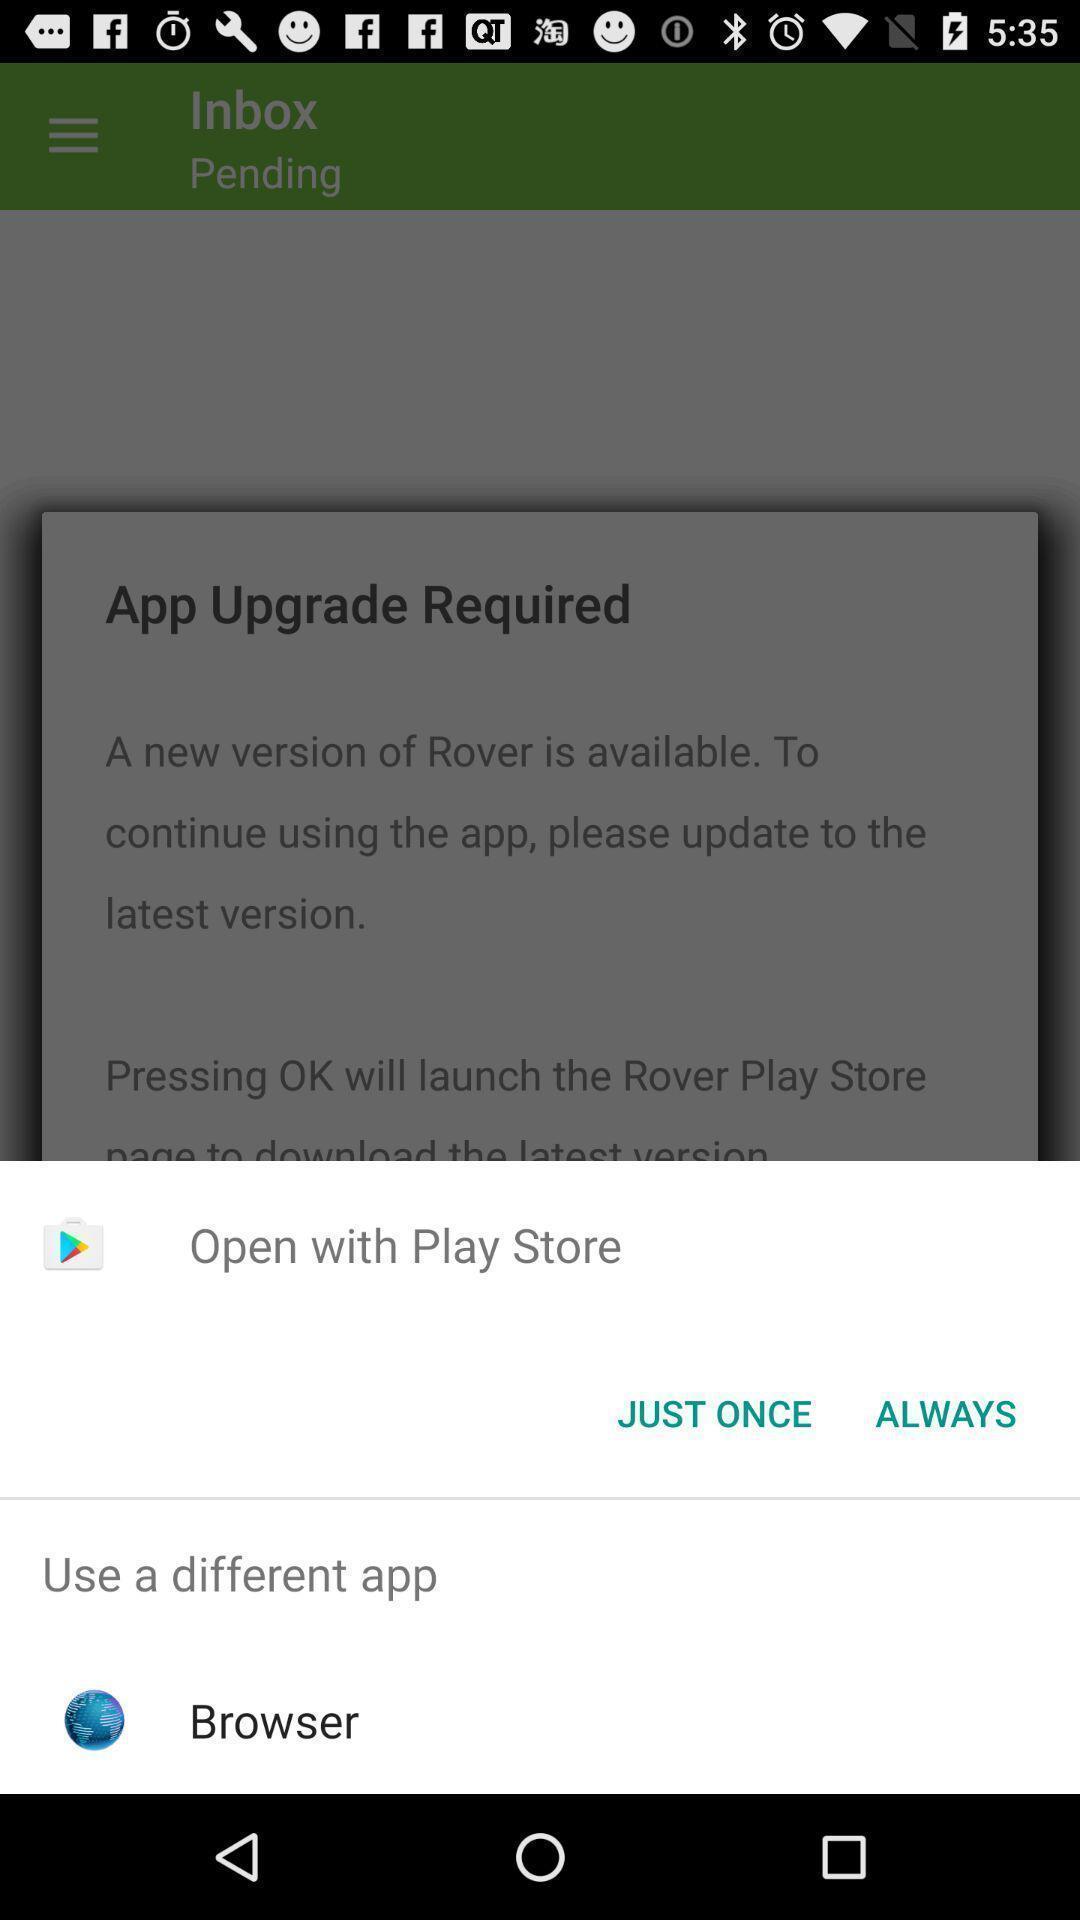Explain what's happening in this screen capture. Share page to select through which browser to complete action. 